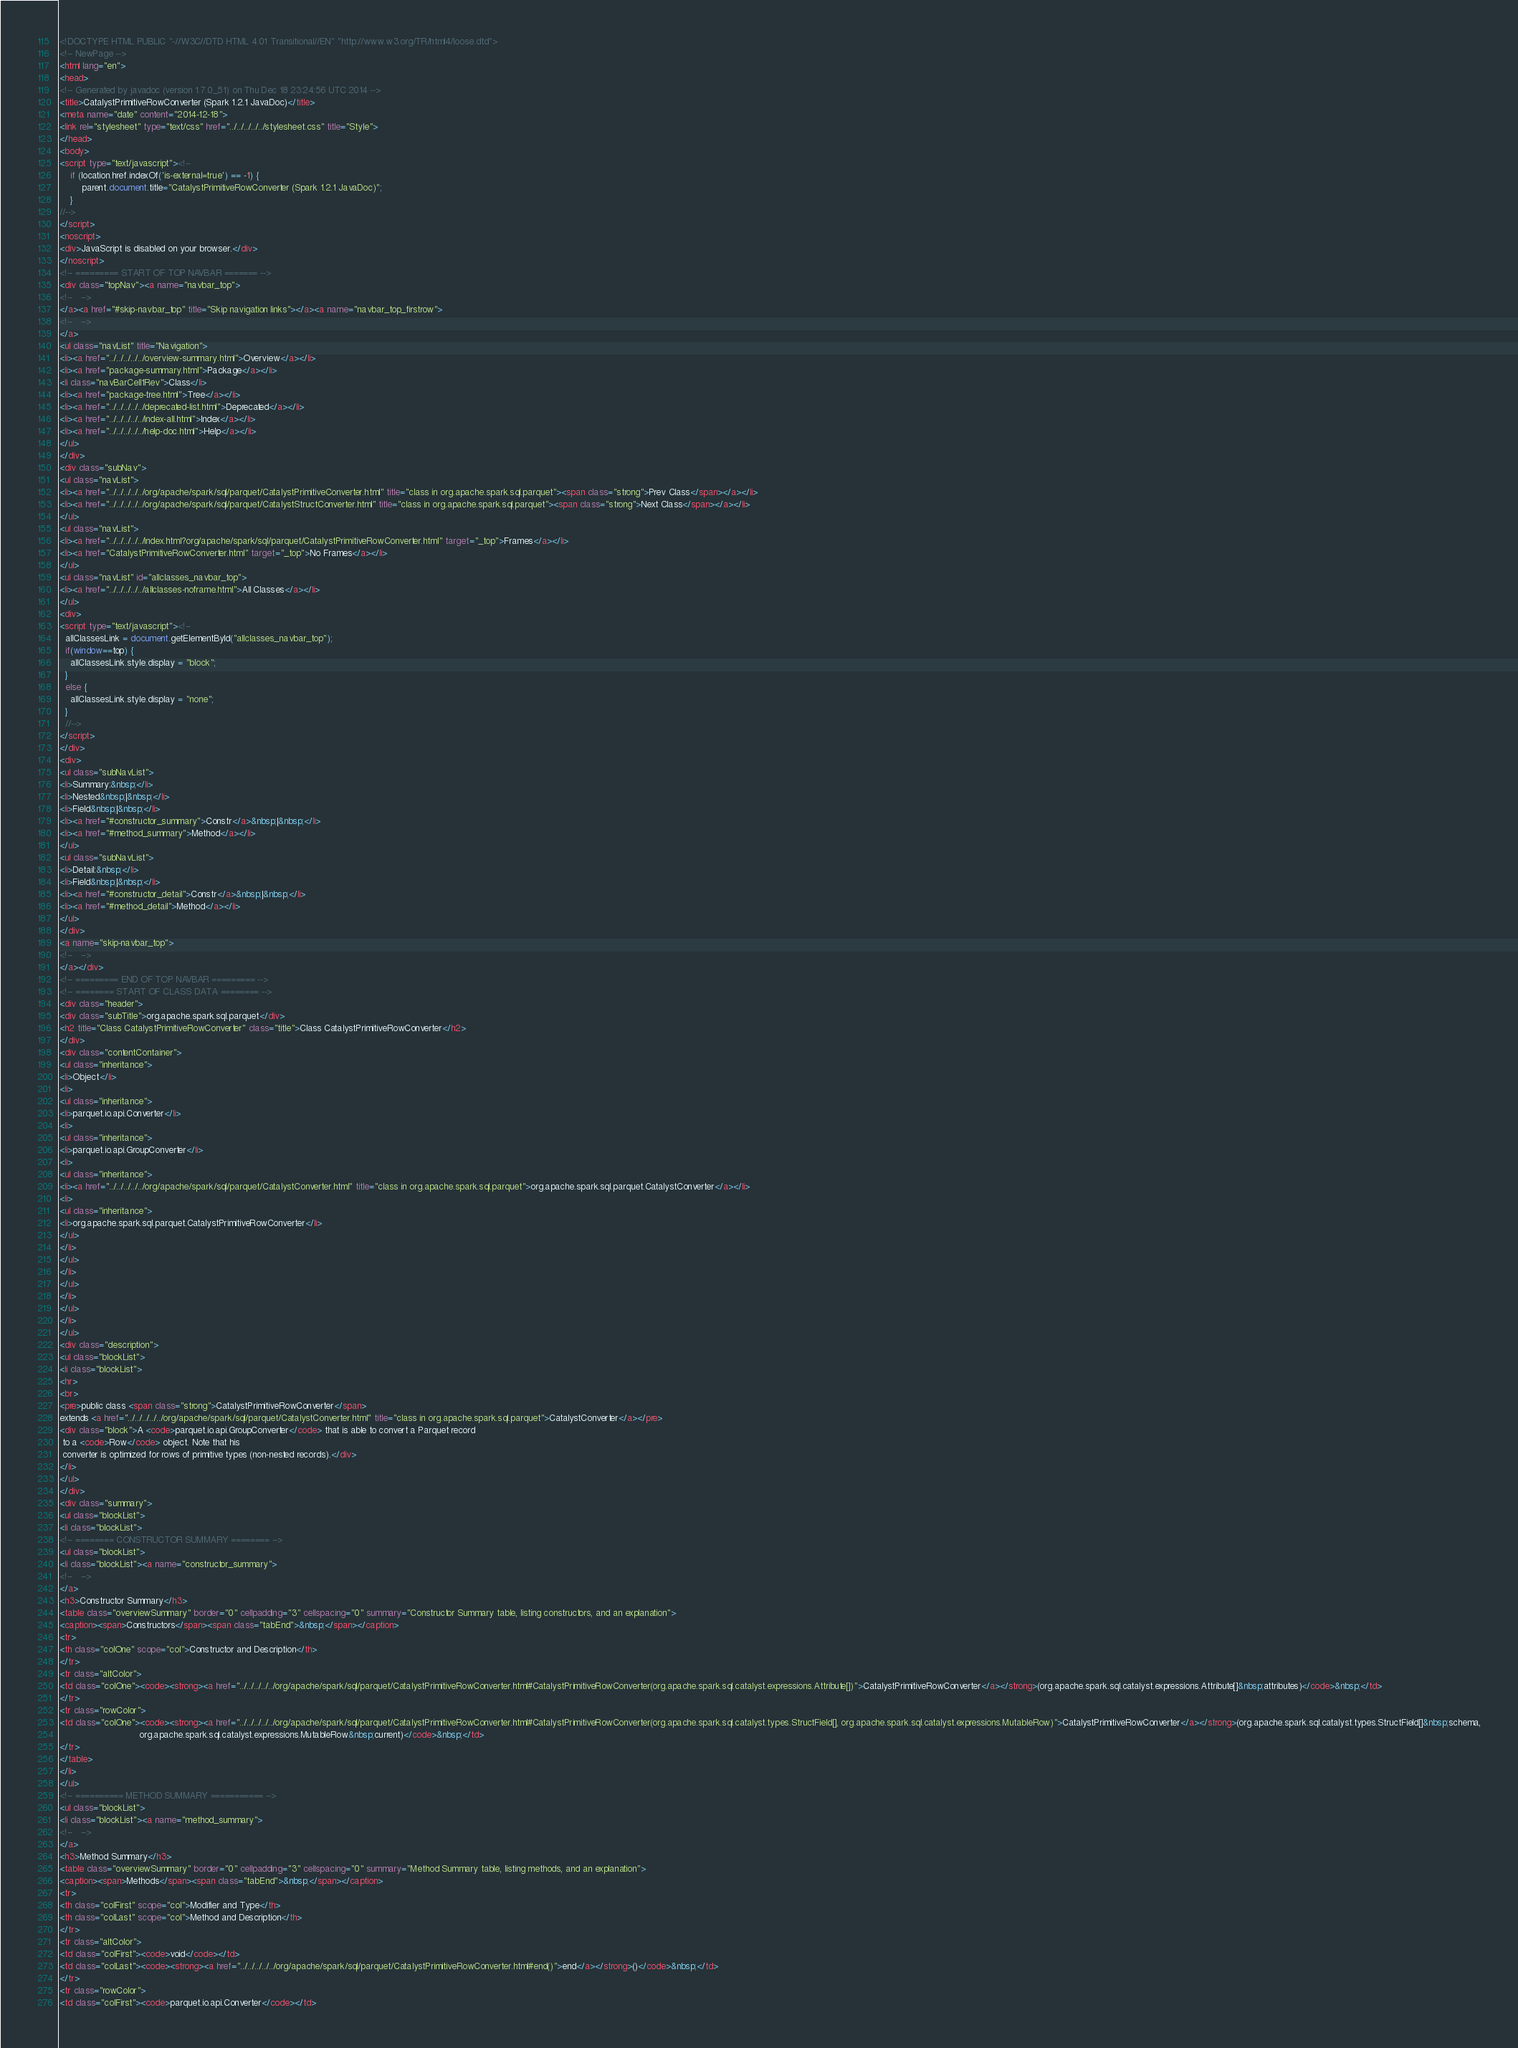Convert code to text. <code><loc_0><loc_0><loc_500><loc_500><_HTML_><!DOCTYPE HTML PUBLIC "-//W3C//DTD HTML 4.01 Transitional//EN" "http://www.w3.org/TR/html4/loose.dtd">
<!-- NewPage -->
<html lang="en">
<head>
<!-- Generated by javadoc (version 1.7.0_51) on Thu Dec 18 23:24:56 UTC 2014 -->
<title>CatalystPrimitiveRowConverter (Spark 1.2.1 JavaDoc)</title>
<meta name="date" content="2014-12-18">
<link rel="stylesheet" type="text/css" href="../../../../../stylesheet.css" title="Style">
</head>
<body>
<script type="text/javascript"><!--
    if (location.href.indexOf('is-external=true') == -1) {
        parent.document.title="CatalystPrimitiveRowConverter (Spark 1.2.1 JavaDoc)";
    }
//-->
</script>
<noscript>
<div>JavaScript is disabled on your browser.</div>
</noscript>
<!-- ========= START OF TOP NAVBAR ======= -->
<div class="topNav"><a name="navbar_top">
<!--   -->
</a><a href="#skip-navbar_top" title="Skip navigation links"></a><a name="navbar_top_firstrow">
<!--   -->
</a>
<ul class="navList" title="Navigation">
<li><a href="../../../../../overview-summary.html">Overview</a></li>
<li><a href="package-summary.html">Package</a></li>
<li class="navBarCell1Rev">Class</li>
<li><a href="package-tree.html">Tree</a></li>
<li><a href="../../../../../deprecated-list.html">Deprecated</a></li>
<li><a href="../../../../../index-all.html">Index</a></li>
<li><a href="../../../../../help-doc.html">Help</a></li>
</ul>
</div>
<div class="subNav">
<ul class="navList">
<li><a href="../../../../../org/apache/spark/sql/parquet/CatalystPrimitiveConverter.html" title="class in org.apache.spark.sql.parquet"><span class="strong">Prev Class</span></a></li>
<li><a href="../../../../../org/apache/spark/sql/parquet/CatalystStructConverter.html" title="class in org.apache.spark.sql.parquet"><span class="strong">Next Class</span></a></li>
</ul>
<ul class="navList">
<li><a href="../../../../../index.html?org/apache/spark/sql/parquet/CatalystPrimitiveRowConverter.html" target="_top">Frames</a></li>
<li><a href="CatalystPrimitiveRowConverter.html" target="_top">No Frames</a></li>
</ul>
<ul class="navList" id="allclasses_navbar_top">
<li><a href="../../../../../allclasses-noframe.html">All Classes</a></li>
</ul>
<div>
<script type="text/javascript"><!--
  allClassesLink = document.getElementById("allclasses_navbar_top");
  if(window==top) {
    allClassesLink.style.display = "block";
  }
  else {
    allClassesLink.style.display = "none";
  }
  //-->
</script>
</div>
<div>
<ul class="subNavList">
<li>Summary:&nbsp;</li>
<li>Nested&nbsp;|&nbsp;</li>
<li>Field&nbsp;|&nbsp;</li>
<li><a href="#constructor_summary">Constr</a>&nbsp;|&nbsp;</li>
<li><a href="#method_summary">Method</a></li>
</ul>
<ul class="subNavList">
<li>Detail:&nbsp;</li>
<li>Field&nbsp;|&nbsp;</li>
<li><a href="#constructor_detail">Constr</a>&nbsp;|&nbsp;</li>
<li><a href="#method_detail">Method</a></li>
</ul>
</div>
<a name="skip-navbar_top">
<!--   -->
</a></div>
<!-- ========= END OF TOP NAVBAR ========= -->
<!-- ======== START OF CLASS DATA ======== -->
<div class="header">
<div class="subTitle">org.apache.spark.sql.parquet</div>
<h2 title="Class CatalystPrimitiveRowConverter" class="title">Class CatalystPrimitiveRowConverter</h2>
</div>
<div class="contentContainer">
<ul class="inheritance">
<li>Object</li>
<li>
<ul class="inheritance">
<li>parquet.io.api.Converter</li>
<li>
<ul class="inheritance">
<li>parquet.io.api.GroupConverter</li>
<li>
<ul class="inheritance">
<li><a href="../../../../../org/apache/spark/sql/parquet/CatalystConverter.html" title="class in org.apache.spark.sql.parquet">org.apache.spark.sql.parquet.CatalystConverter</a></li>
<li>
<ul class="inheritance">
<li>org.apache.spark.sql.parquet.CatalystPrimitiveRowConverter</li>
</ul>
</li>
</ul>
</li>
</ul>
</li>
</ul>
</li>
</ul>
<div class="description">
<ul class="blockList">
<li class="blockList">
<hr>
<br>
<pre>public class <span class="strong">CatalystPrimitiveRowConverter</span>
extends <a href="../../../../../org/apache/spark/sql/parquet/CatalystConverter.html" title="class in org.apache.spark.sql.parquet">CatalystConverter</a></pre>
<div class="block">A <code>parquet.io.api.GroupConverter</code> that is able to convert a Parquet record
 to a <code>Row</code> object. Note that his
 converter is optimized for rows of primitive types (non-nested records).</div>
</li>
</ul>
</div>
<div class="summary">
<ul class="blockList">
<li class="blockList">
<!-- ======== CONSTRUCTOR SUMMARY ======== -->
<ul class="blockList">
<li class="blockList"><a name="constructor_summary">
<!--   -->
</a>
<h3>Constructor Summary</h3>
<table class="overviewSummary" border="0" cellpadding="3" cellspacing="0" summary="Constructor Summary table, listing constructors, and an explanation">
<caption><span>Constructors</span><span class="tabEnd">&nbsp;</span></caption>
<tr>
<th class="colOne" scope="col">Constructor and Description</th>
</tr>
<tr class="altColor">
<td class="colOne"><code><strong><a href="../../../../../org/apache/spark/sql/parquet/CatalystPrimitiveRowConverter.html#CatalystPrimitiveRowConverter(org.apache.spark.sql.catalyst.expressions.Attribute[])">CatalystPrimitiveRowConverter</a></strong>(org.apache.spark.sql.catalyst.expressions.Attribute[]&nbsp;attributes)</code>&nbsp;</td>
</tr>
<tr class="rowColor">
<td class="colOne"><code><strong><a href="../../../../../org/apache/spark/sql/parquet/CatalystPrimitiveRowConverter.html#CatalystPrimitiveRowConverter(org.apache.spark.sql.catalyst.types.StructField[], org.apache.spark.sql.catalyst.expressions.MutableRow)">CatalystPrimitiveRowConverter</a></strong>(org.apache.spark.sql.catalyst.types.StructField[]&nbsp;schema,
                             org.apache.spark.sql.catalyst.expressions.MutableRow&nbsp;current)</code>&nbsp;</td>
</tr>
</table>
</li>
</ul>
<!-- ========== METHOD SUMMARY =========== -->
<ul class="blockList">
<li class="blockList"><a name="method_summary">
<!--   -->
</a>
<h3>Method Summary</h3>
<table class="overviewSummary" border="0" cellpadding="3" cellspacing="0" summary="Method Summary table, listing methods, and an explanation">
<caption><span>Methods</span><span class="tabEnd">&nbsp;</span></caption>
<tr>
<th class="colFirst" scope="col">Modifier and Type</th>
<th class="colLast" scope="col">Method and Description</th>
</tr>
<tr class="altColor">
<td class="colFirst"><code>void</code></td>
<td class="colLast"><code><strong><a href="../../../../../org/apache/spark/sql/parquet/CatalystPrimitiveRowConverter.html#end()">end</a></strong>()</code>&nbsp;</td>
</tr>
<tr class="rowColor">
<td class="colFirst"><code>parquet.io.api.Converter</code></td></code> 